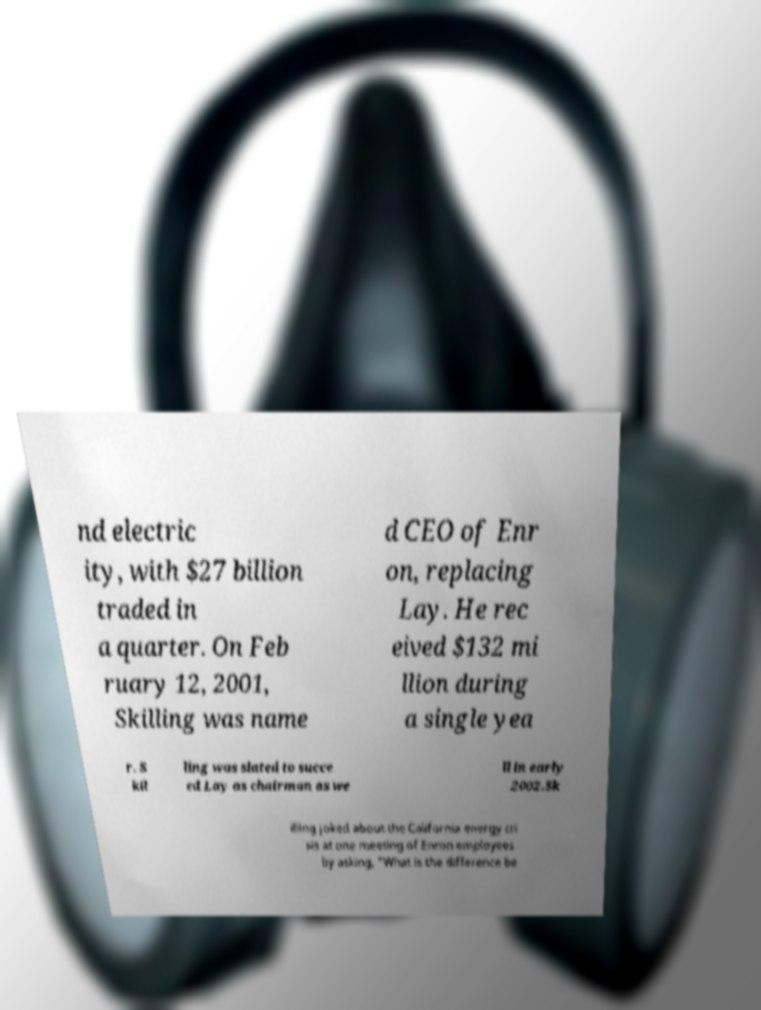What messages or text are displayed in this image? I need them in a readable, typed format. nd electric ity, with $27 billion traded in a quarter. On Feb ruary 12, 2001, Skilling was name d CEO of Enr on, replacing Lay. He rec eived $132 mi llion during a single yea r. S kil ling was slated to succe ed Lay as chairman as we ll in early 2002.Sk illing joked about the California energy cri sis at one meeting of Enron employees by asking, "What is the difference be 